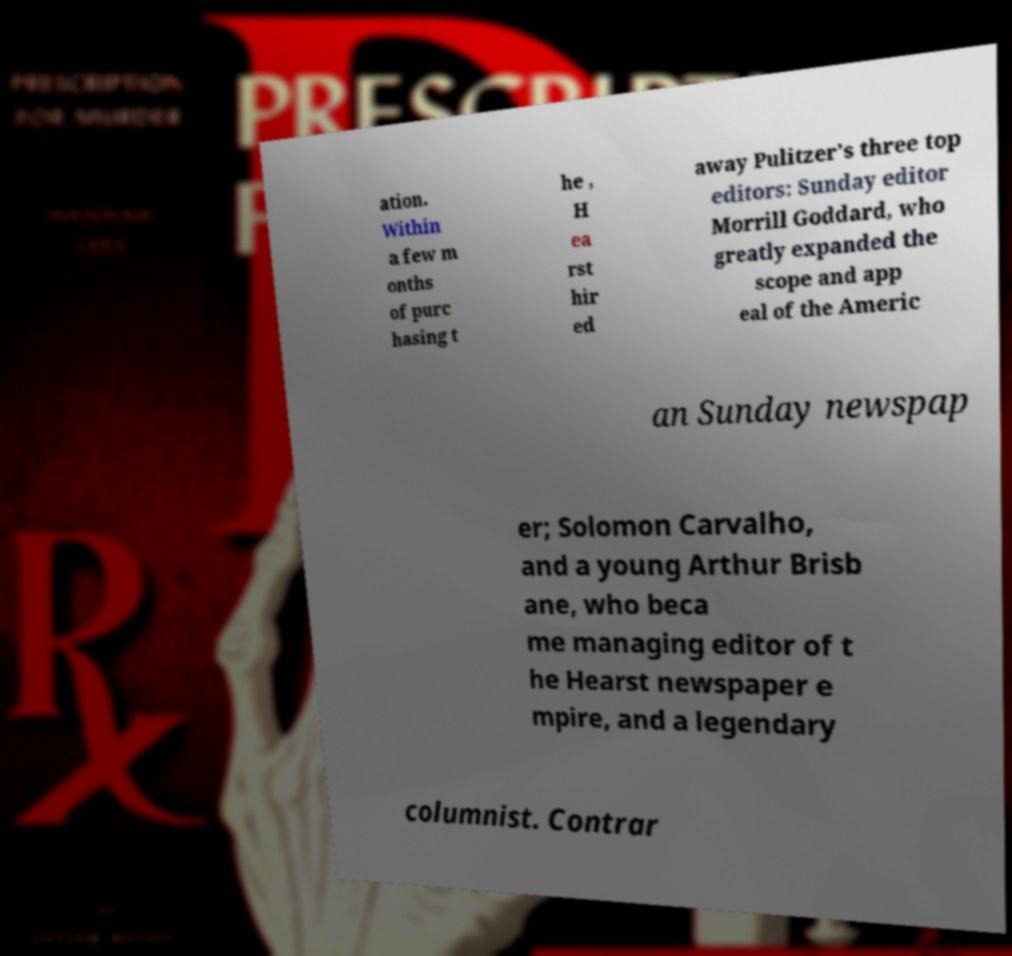Please identify and transcribe the text found in this image. ation. Within a few m onths of purc hasing t he , H ea rst hir ed away Pulitzer's three top editors: Sunday editor Morrill Goddard, who greatly expanded the scope and app eal of the Americ an Sunday newspap er; Solomon Carvalho, and a young Arthur Brisb ane, who beca me managing editor of t he Hearst newspaper e mpire, and a legendary columnist. Contrar 